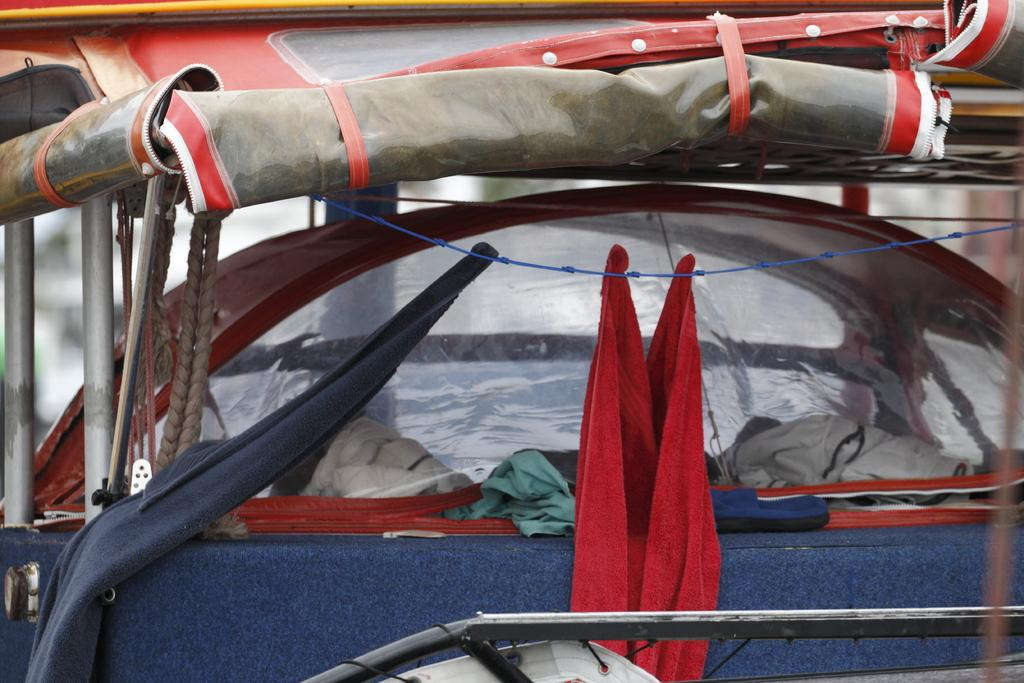What is the vehicle in the image used for? The vehicle with clothes in the image is likely a clothesline or drying rack. What can be seen on the left side of the image? There are ropes on the left side of the image. What type of material is used for the rods in the image? The rods in the image are made of metal. Can you describe the position of the metal rod at the bottom of the image? There is a metal rod at the bottom of the image, likely supporting the structure. What is hanging from a wire in the image? A cloth is hanging from a wire in the image. What time of day is depicted in the image? The time of day is not visible or mentioned in the image, so it cannot be determined. 